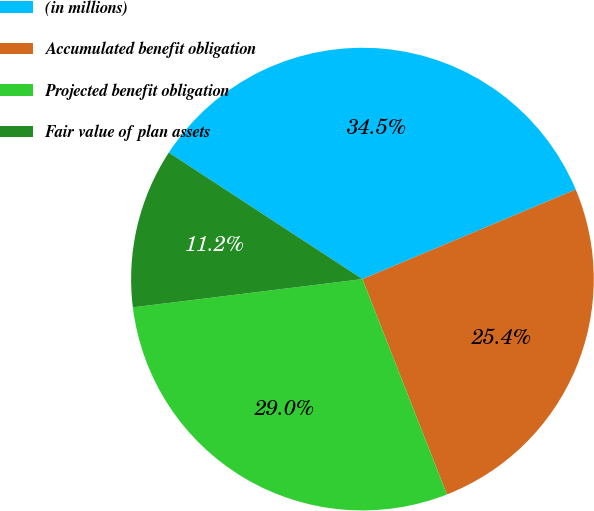<chart> <loc_0><loc_0><loc_500><loc_500><pie_chart><fcel>(in millions)<fcel>Accumulated benefit obligation<fcel>Projected benefit obligation<fcel>Fair value of plan assets<nl><fcel>34.46%<fcel>25.38%<fcel>29.0%<fcel>11.16%<nl></chart> 